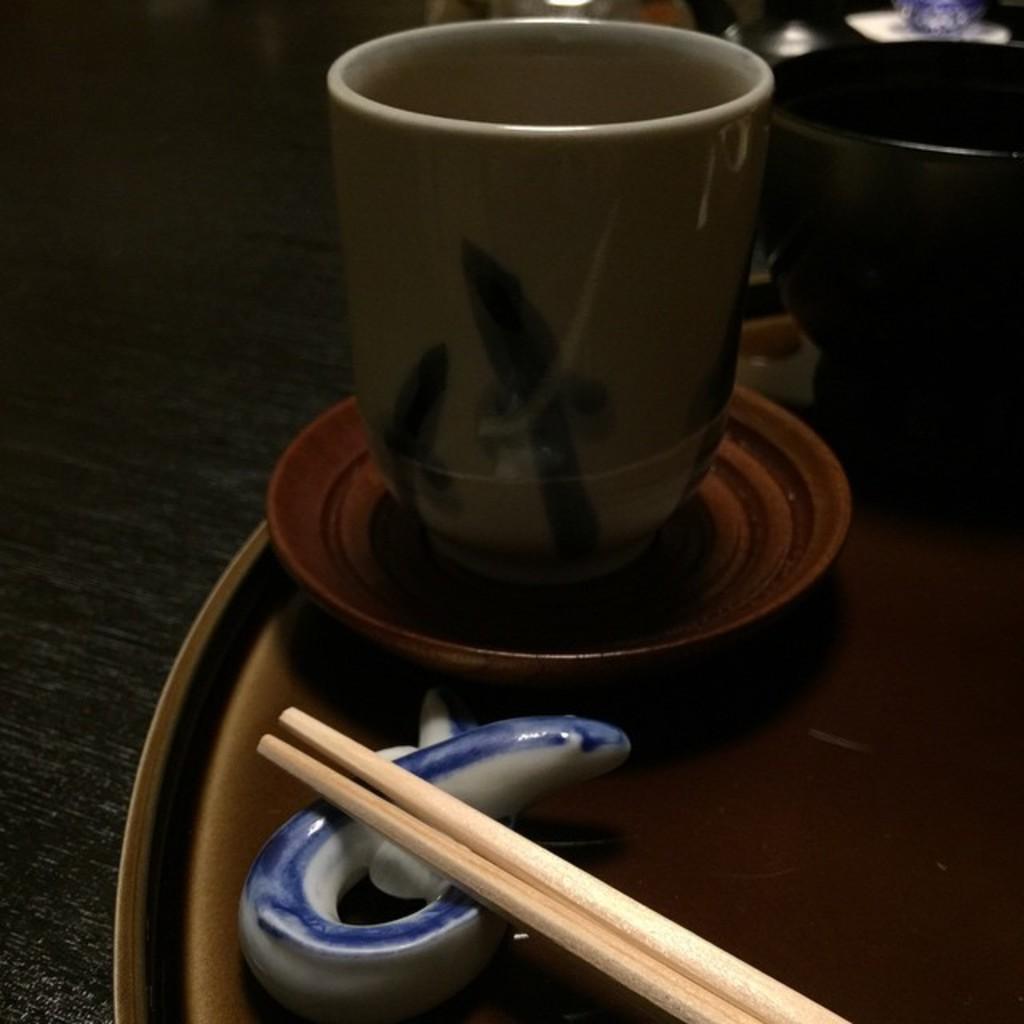Could you give a brief overview of what you see in this image? In the picture we can see a cup, saucer, on the plate and in the plate we can see two chopsticks which is placed on the table. 